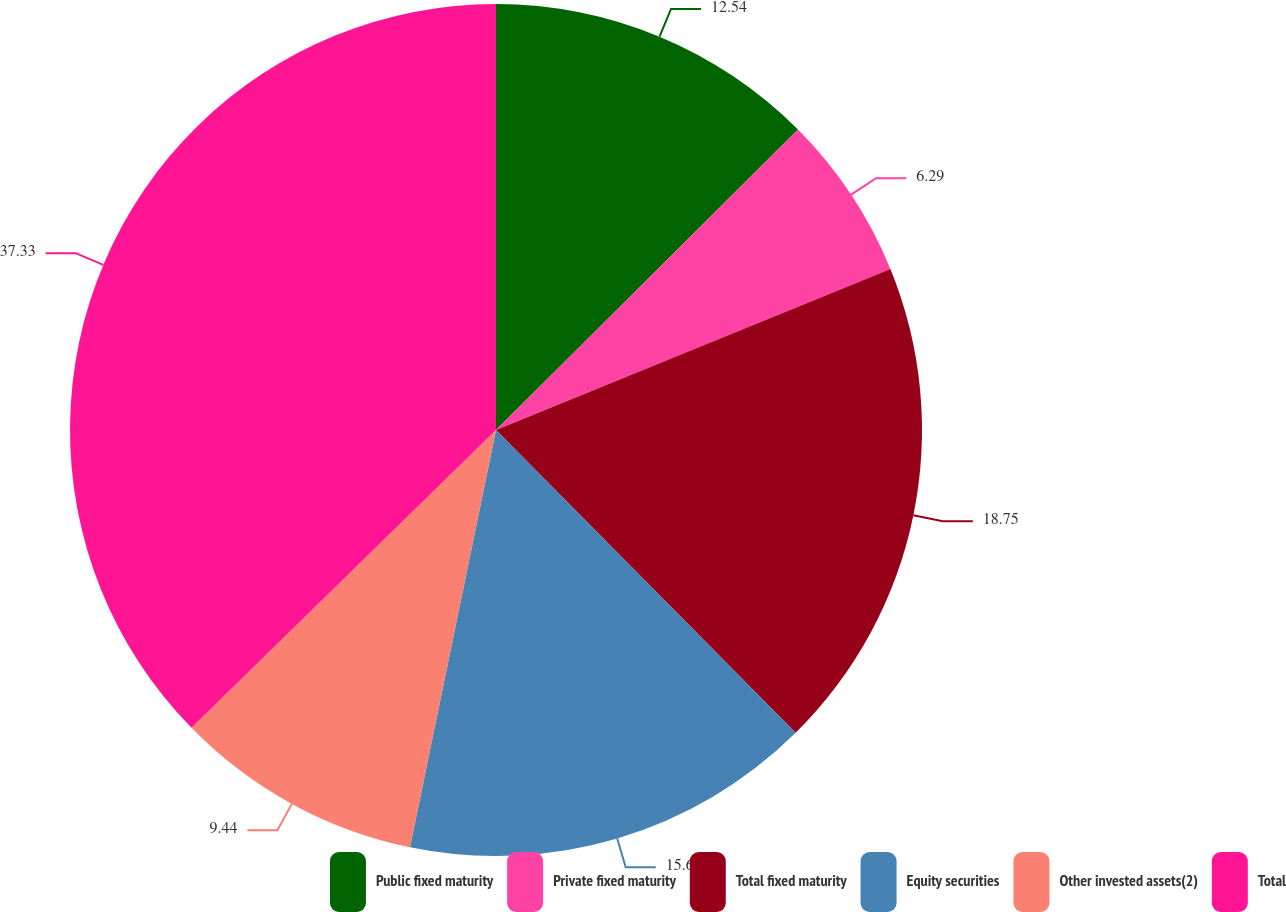<chart> <loc_0><loc_0><loc_500><loc_500><pie_chart><fcel>Public fixed maturity<fcel>Private fixed maturity<fcel>Total fixed maturity<fcel>Equity securities<fcel>Other invested assets(2)<fcel>Total<nl><fcel>12.54%<fcel>6.29%<fcel>18.75%<fcel>15.65%<fcel>9.44%<fcel>37.32%<nl></chart> 